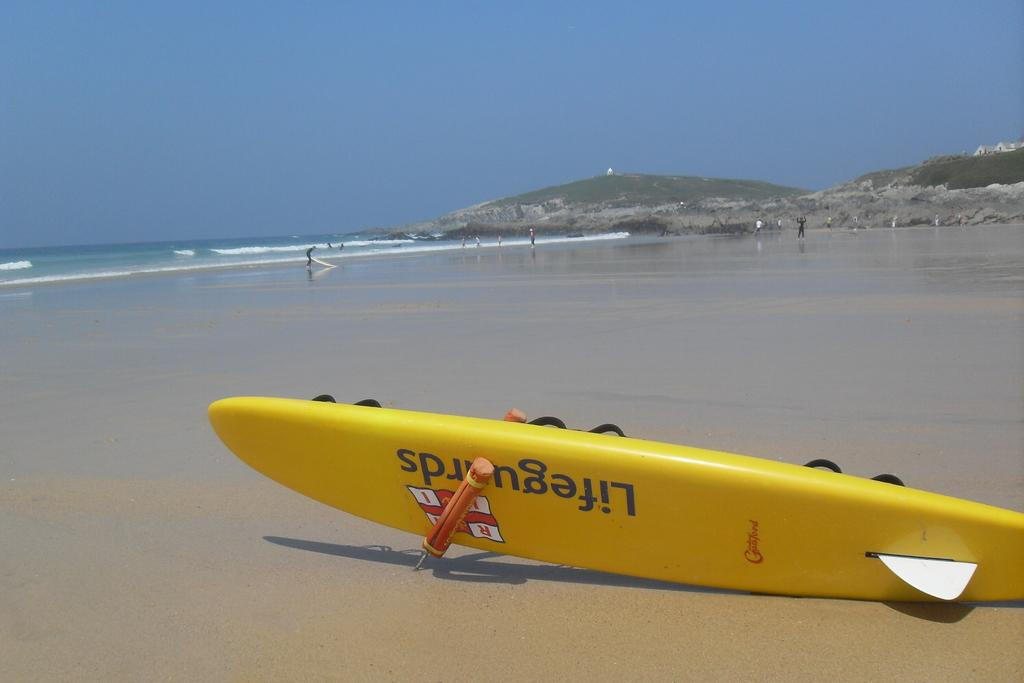Provide a one-sentence caption for the provided image. A yellow Lifeguards surfboard is sitting on an empty beach tipped on its side. 